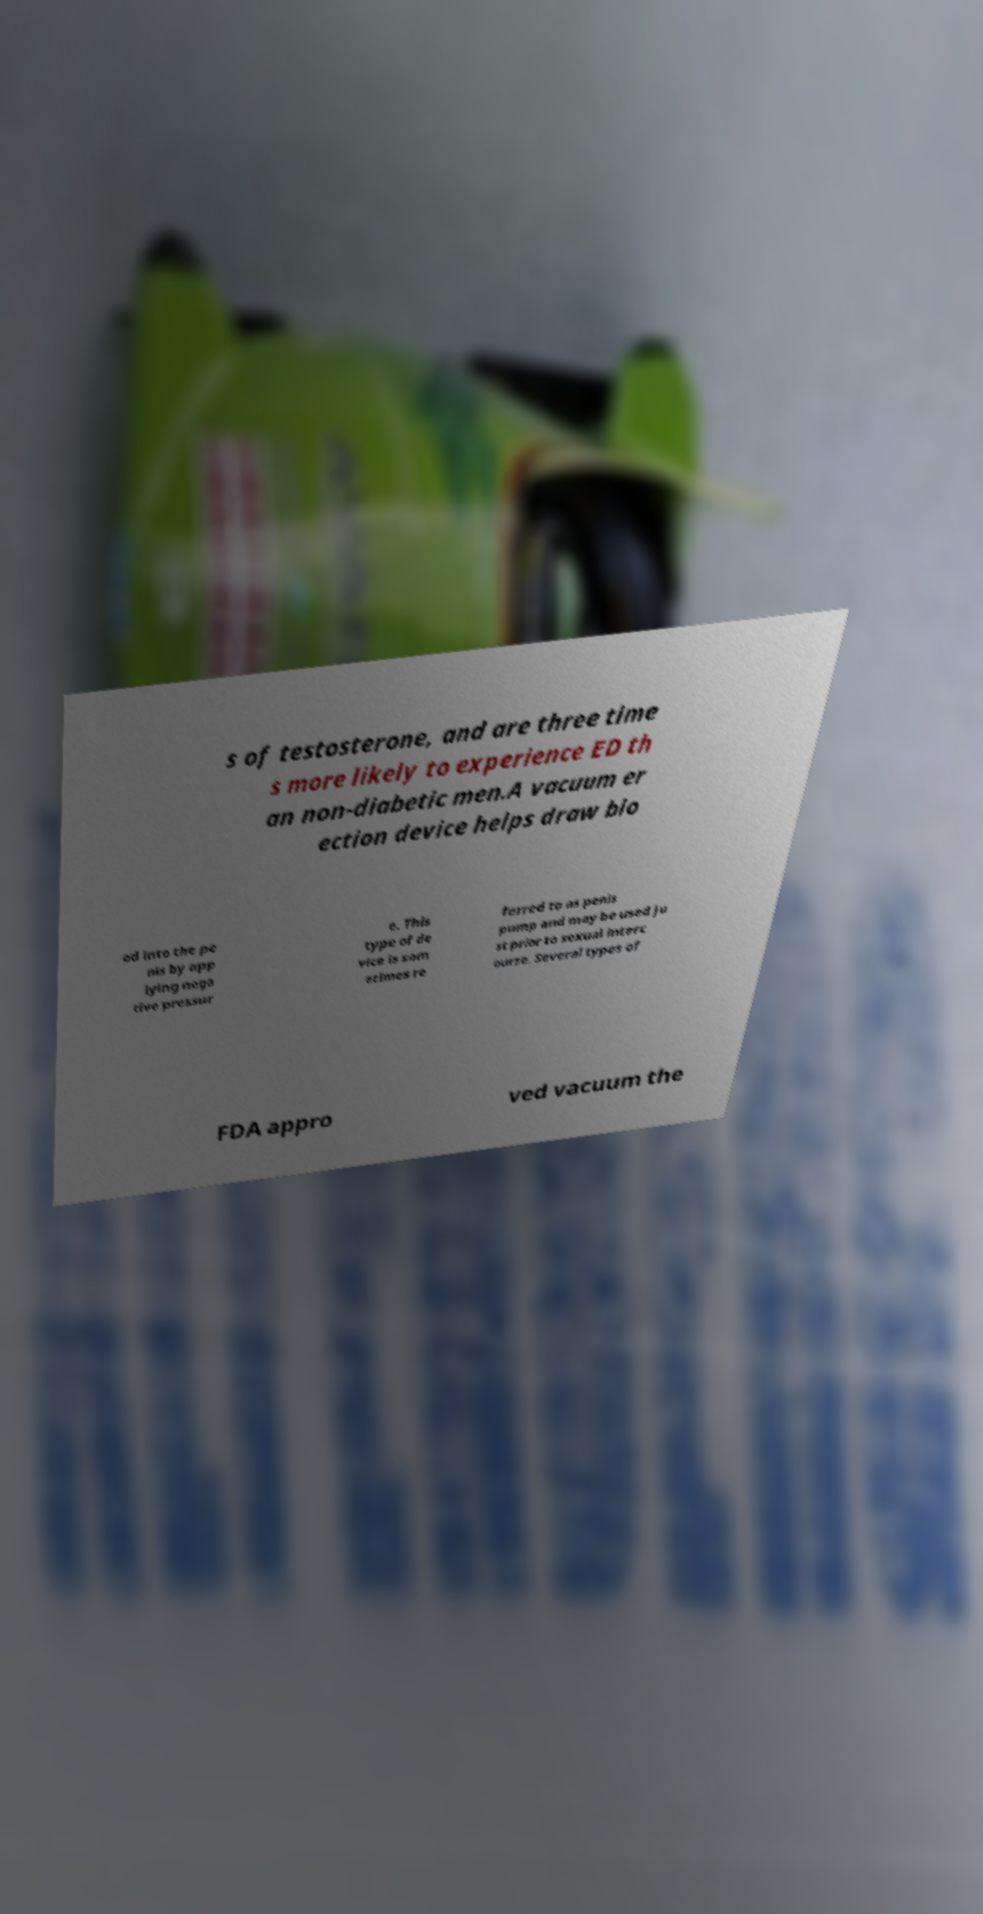I need the written content from this picture converted into text. Can you do that? s of testosterone, and are three time s more likely to experience ED th an non-diabetic men.A vacuum er ection device helps draw blo od into the pe nis by app lying nega tive pressur e. This type of de vice is som etimes re ferred to as penis pump and may be used ju st prior to sexual interc ourse. Several types of FDA appro ved vacuum the 